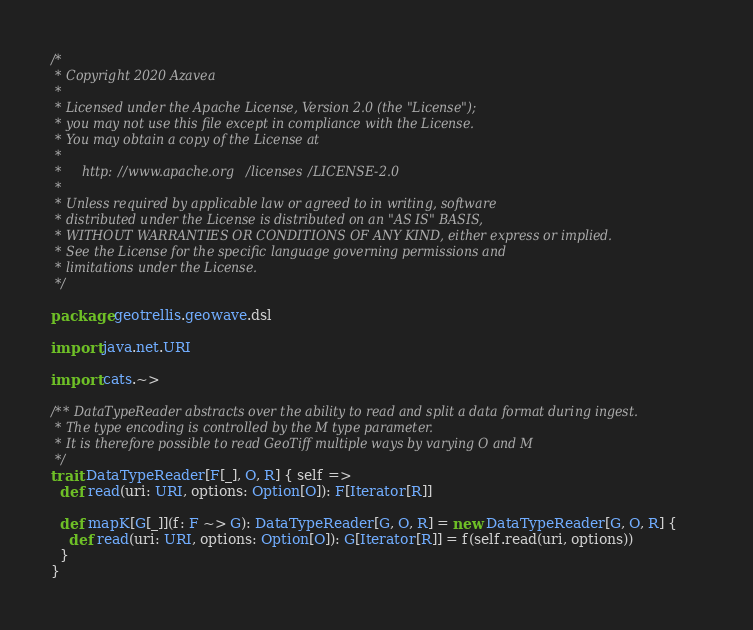Convert code to text. <code><loc_0><loc_0><loc_500><loc_500><_Scala_>/*
 * Copyright 2020 Azavea
 *
 * Licensed under the Apache License, Version 2.0 (the "License");
 * you may not use this file except in compliance with the License.
 * You may obtain a copy of the License at
 *
 *     http://www.apache.org/licenses/LICENSE-2.0
 *
 * Unless required by applicable law or agreed to in writing, software
 * distributed under the License is distributed on an "AS IS" BASIS,
 * WITHOUT WARRANTIES OR CONDITIONS OF ANY KIND, either express or implied.
 * See the License for the specific language governing permissions and
 * limitations under the License.
 */

package geotrellis.geowave.dsl

import java.net.URI

import cats.~>

/** DataTypeReader abstracts over the ability to read and split a data format during ingest.
 * The type encoding is controlled by the M type parameter.
 * It is therefore possible to read GeoTiff multiple ways by varying O and M
 */
trait DataTypeReader[F[_], O, R] { self =>
  def read(uri: URI, options: Option[O]): F[Iterator[R]]

  def mapK[G[_]](f: F ~> G): DataTypeReader[G, O, R] = new DataTypeReader[G, O, R] {
    def read(uri: URI, options: Option[O]): G[Iterator[R]] = f(self.read(uri, options))
  }
}</code> 